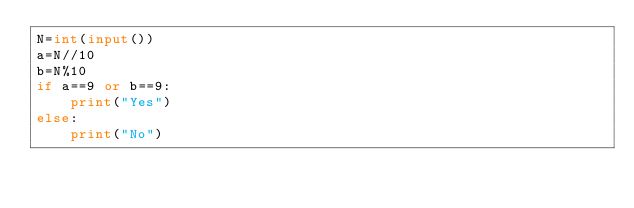Convert code to text. <code><loc_0><loc_0><loc_500><loc_500><_Python_>N=int(input())
a=N//10
b=N%10
if a==9 or b==9:
    print("Yes")
else:
    print("No")</code> 